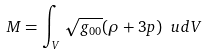<formula> <loc_0><loc_0><loc_500><loc_500>M = \int _ { V } \sqrt { g _ { 0 0 } } ( \rho + 3 p ) \ u d V</formula> 